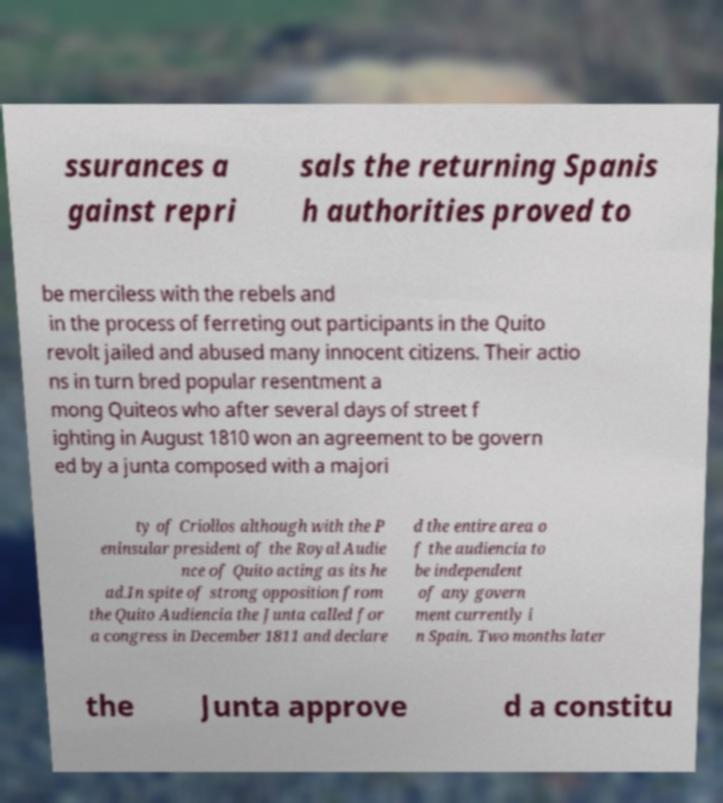I need the written content from this picture converted into text. Can you do that? ssurances a gainst repri sals the returning Spanis h authorities proved to be merciless with the rebels and in the process of ferreting out participants in the Quito revolt jailed and abused many innocent citizens. Their actio ns in turn bred popular resentment a mong Quiteos who after several days of street f ighting in August 1810 won an agreement to be govern ed by a junta composed with a majori ty of Criollos although with the P eninsular president of the Royal Audie nce of Quito acting as its he ad.In spite of strong opposition from the Quito Audiencia the Junta called for a congress in December 1811 and declare d the entire area o f the audiencia to be independent of any govern ment currently i n Spain. Two months later the Junta approve d a constitu 